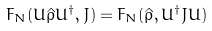Convert formula to latex. <formula><loc_0><loc_0><loc_500><loc_500>F _ { N } ( U \hat { \rho } U ^ { \dagger } , J ) = F _ { N } ( \hat { \rho } , U ^ { \dagger } J U )</formula> 